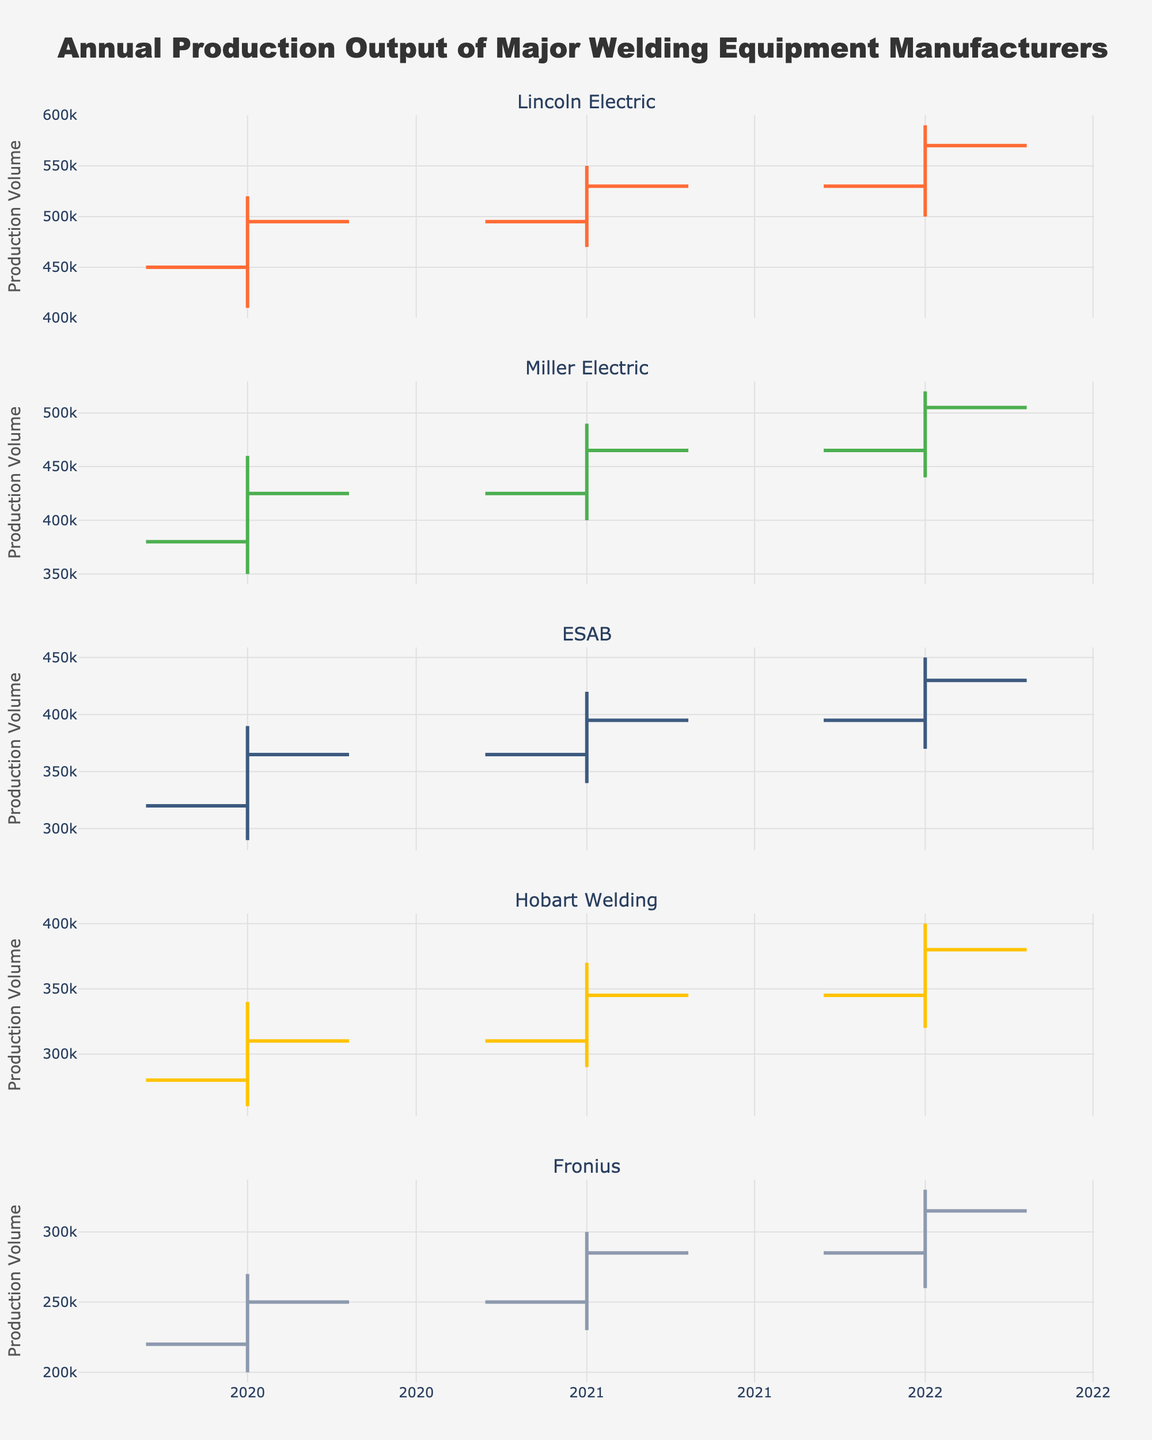What is the title of the chart? The title can be found at the top of the chart. It reads, "Annual Production Output of Major Welding Equipment Manufacturers".
Answer: Annual Production Output of Major Welding Equipment Manufacturers Which manufacturer's production volume showed the largest increase from 2020 to 2022? To find the largest increase, look at the closing values for each manufacturer in 2020 and compare it with the closing value in 2022. Calculate the difference for each and find the largest. Lincoln Electric's increase is 570000 - 495000 = 75000, which is the largest.
Answer: Lincoln Electric What is the overall trend for Fronius from 2020 to 2022? For finding trends, compare the opening and closing values over the years. In 2020, the closing was 250000 and in 2021, it was 285000, which is an increase. From 2021 to 2022, it increased again to 315000. So, the trend is consistently increasing.
Answer: Increasing Which manufacturer had the highest production volume in any year? Look for the highest value in the highest column across all manufacturers and years. Lincoln Electric had the highest production volume at 590000 in 2022.
Answer: Lincoln Electric In which year did Miller Electric have its lowest production volume, and what was that volume? Look at the lowest values for Miller Electric across the years. The lowest was 350000 in the year 2020.
Answer: 2020, 350000 Which manufacturers had a higher closing value in 2022 compared to their opening value in 2022? Compare the opening and closing values for each manufacturer in 2022. If closing > opening, then it has increased. Lincoln Electric (570000 > 530000), Miller Electric (505000 > 465000), ESAB (430000 > 395000), Hobart Welding (380000 > 345000), and Fronius (315000 > 285000) all had higher closing values compared to opening in 2022.
Answer: Lincoln Electric, Miller Electric, ESAB, Hobart Welding, Fronius Between ESAB and Hobart Welding, which manufacturer had a more significant drop in production volume in any single year, and how much was it? Calculate the drop for each by comparing the highest and the lowest values in the same year. ESAB's drop in 2020 was 390000 - 290000 = 100000. Hobart Welding's drop in 2020 was 340000 - 260000 = 80000. So, ESAB had a more significant drop.
Answer: ESAB, 100000 Which year did Lincoln Electric close with the highest production volume, and what was the volume? Look at Lincoln Electric's closing values across the years and find the highest. The highest closing was in 2022 at 570000.
Answer: 2022, 570000 How did the production volume for Miller Electric change from 2020 to 2021? Compare Miller Electric's closing values from 2020 (425000) and 2021 (465000). The change is 465000 - 425000 = 40000. The production volume increased by 40000.
Answer: Increased by 40000 What was the average closing production volume for ESAB over the three years? Add up the closing values for ESAB from 2020 to 2022 and divide by 3. The total is 365000 + 395000 + 430000 = 1190000. The average is 1190000 / 3 = 396667 (rounded to the nearest unit).
Answer: 396667 